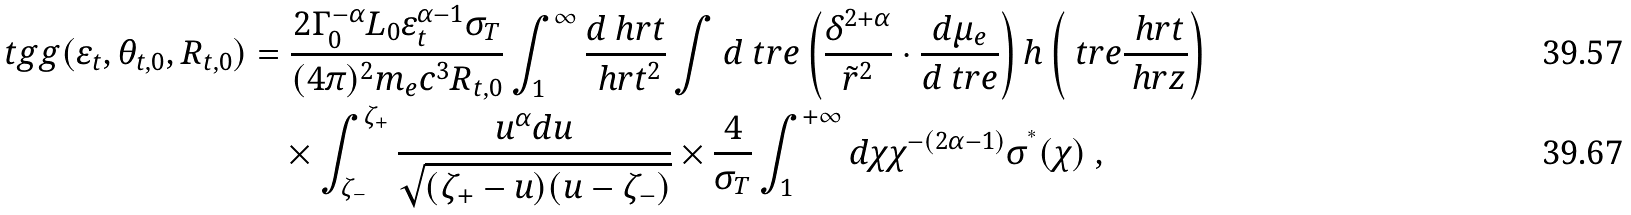Convert formula to latex. <formula><loc_0><loc_0><loc_500><loc_500>\ t g g ( \varepsilon _ { t } , \theta _ { t , 0 } , R _ { t , 0 } ) & = \frac { 2 \Gamma _ { 0 } ^ { - \alpha } L _ { 0 } \varepsilon _ { t } ^ { \alpha - 1 } \sigma _ { T } } { ( 4 \pi ) ^ { 2 } m _ { e } c ^ { 3 } R _ { t , 0 } } \int _ { 1 } ^ { \infty } \frac { d \ h r t } { \ h r t ^ { 2 } } \int d \ t r e \left ( \frac { \delta ^ { 2 + \alpha } } { \tilde { r } ^ { 2 } } \cdot \frac { d \mu _ { e } } { d \ t r e } \right ) h \left ( \ t r e \frac { \ h r t } { \ h r z } \right ) \\ & \quad \times \int _ { \zeta _ { - } } ^ { \zeta _ { + } } \frac { u ^ { \alpha } d u } { \sqrt { ( \zeta _ { + } - u ) ( u - \zeta _ { - } ) } } \times \frac { 4 } { \sigma _ { T } } \int _ { 1 } ^ { + \infty } d \chi \chi ^ { - ( 2 \alpha - 1 ) } \sigma ^ { ^ { * } } ( \chi ) \ ,</formula> 